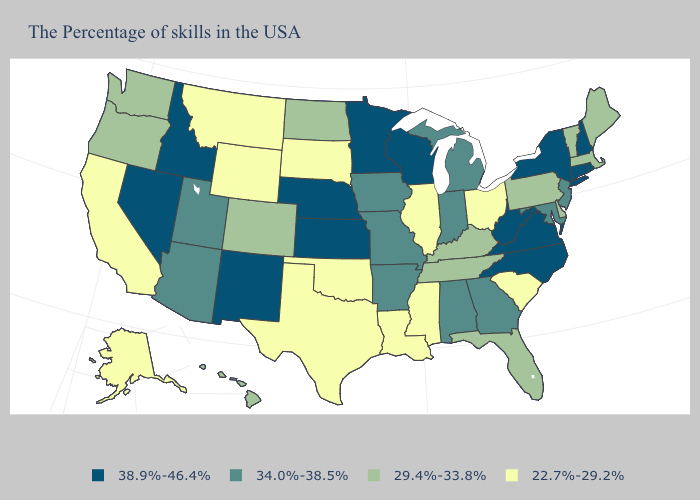What is the value of New Hampshire?
Answer briefly. 38.9%-46.4%. Does Pennsylvania have a lower value than Tennessee?
Give a very brief answer. No. Does the map have missing data?
Concise answer only. No. What is the value of Arkansas?
Quick response, please. 34.0%-38.5%. What is the highest value in the USA?
Short answer required. 38.9%-46.4%. Name the states that have a value in the range 22.7%-29.2%?
Give a very brief answer. South Carolina, Ohio, Illinois, Mississippi, Louisiana, Oklahoma, Texas, South Dakota, Wyoming, Montana, California, Alaska. What is the value of Maryland?
Be succinct. 34.0%-38.5%. Name the states that have a value in the range 38.9%-46.4%?
Write a very short answer. Rhode Island, New Hampshire, Connecticut, New York, Virginia, North Carolina, West Virginia, Wisconsin, Minnesota, Kansas, Nebraska, New Mexico, Idaho, Nevada. What is the value of Delaware?
Short answer required. 29.4%-33.8%. What is the lowest value in the USA?
Be succinct. 22.7%-29.2%. Name the states that have a value in the range 22.7%-29.2%?
Answer briefly. South Carolina, Ohio, Illinois, Mississippi, Louisiana, Oklahoma, Texas, South Dakota, Wyoming, Montana, California, Alaska. Does Delaware have a lower value than Indiana?
Keep it brief. Yes. Name the states that have a value in the range 34.0%-38.5%?
Write a very short answer. New Jersey, Maryland, Georgia, Michigan, Indiana, Alabama, Missouri, Arkansas, Iowa, Utah, Arizona. What is the value of North Carolina?
Short answer required. 38.9%-46.4%. What is the value of Colorado?
Give a very brief answer. 29.4%-33.8%. 